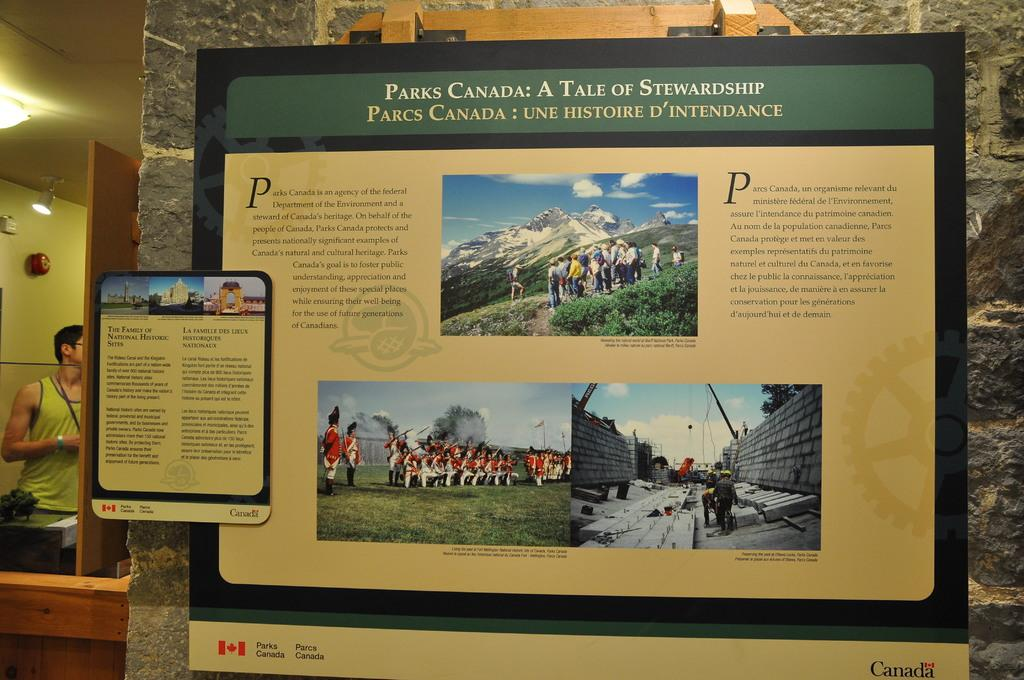<image>
Offer a succinct explanation of the picture presented. A display in a frame titled Parks Canada. 